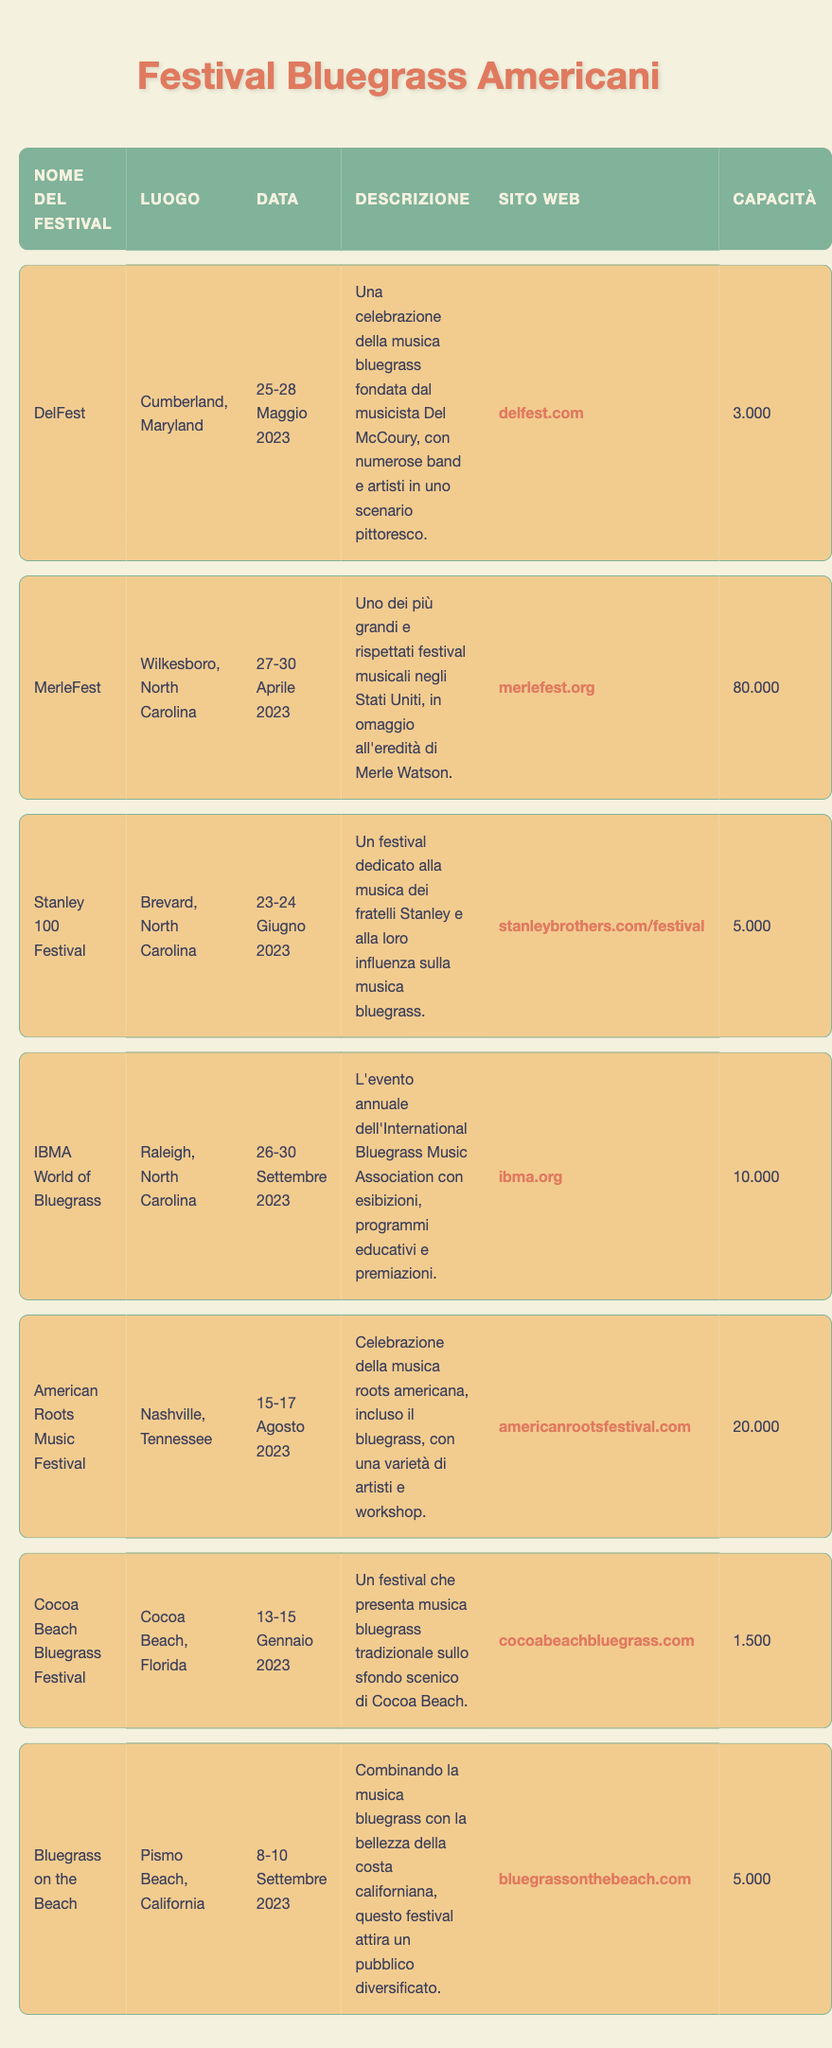What is the location of MerleFest? The location of MerleFest can be found in the second row of the table under the "Luogo" column. It shows "Wilkesboro, North Carolina."
Answer: Wilkesboro, North Carolina Which festival has the largest capacity? To find the festival with the largest capacity, we can look at the "Capacità" column and determine the maximum value. The maximum capacity listed is 80,000 for MerleFest.
Answer: 80,000 Is the Cocoa Beach Bluegrass Festival scheduled for the same month as the American Roots Music Festival? Checking the "Data" column, Cocoa Beach Bluegrass Festival is scheduled for January 13-15, 2023, while the American Roots Music Festival is on August 15-17, 2023. Since January and August are different months, the answer is no.
Answer: No How many festivals take place in North Carolina? We need to count the number of entries in the table where the "Luogo" column is listed as North Carolina. The festivals are MerleFest, Stanley 100 Festival, and IBMA World of Bluegrass, giving us a total of three festivals.
Answer: 3 What is the average capacity of the festivals in the table? To compute the average capacity, first we sum all capacities: 3,000 (DelFest) + 80,000 (MerleFest) + 5,000 (Stanley 100 Festival) + 10,000 (IBMA World of Bluegrass) + 20,000 (American Roots Music Festival) + 1,500 (Cocoa Beach Bluegrass Festival) + 5,000 (Bluegrass on the Beach) = 124,500. Next, there are 7 festivals total, so we divide by 7: 124,500 / 7 ≈ 17,785.71. Therefore, the average capacity is approximately 17,786.
Answer: 17,786 Does the Stanley 100 Festival have a higher capacity than the Cocoa Beach Bluegrass Festival? Comparing the values in the "Capacità" column, Stanley 100 Festival has a capacity of 5,000, while Cocoa Beach Bluegrass Festival has a capacity of 1,500. Since 5,000 is greater than 1,500, the answer is yes.
Answer: Yes 